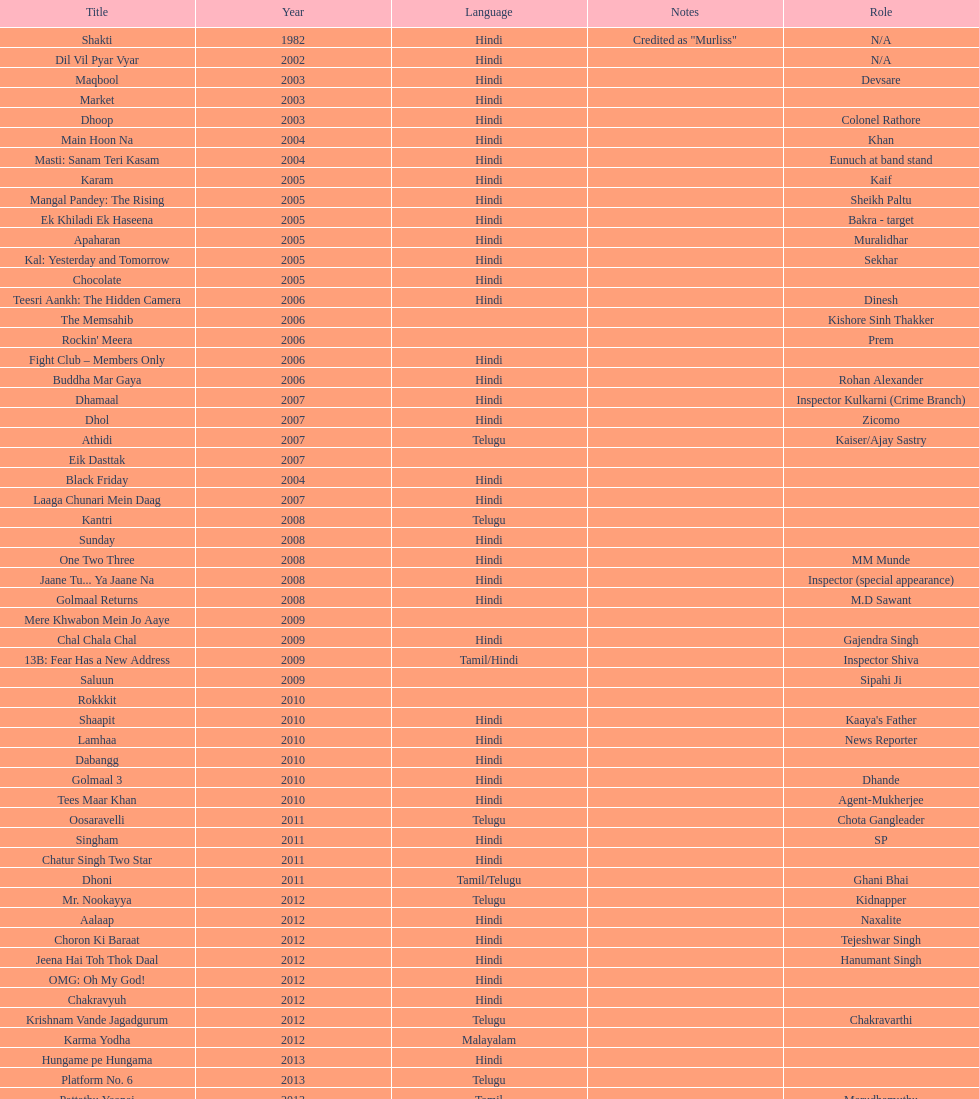What movie did this actor star in after they starred in dil vil pyar vyar in 2002? Maqbool. 